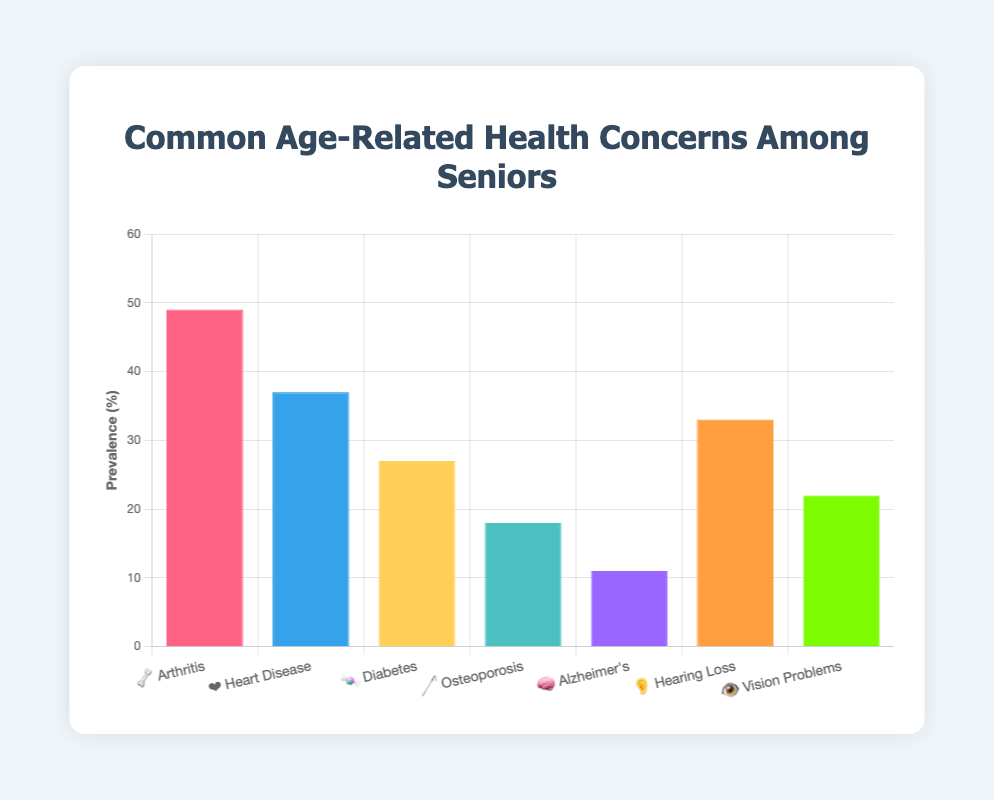Which health concern has the highest prevalence among seniors? Looking at the chart, identify the health concern with the tallest bar representing the highest prevalence percentage. "Arthritis" with an emoji 🦴 has the highest bar at 49%.
Answer: Arthritis 🦴 Which health concern has the lowest prevalence among seniors? Identify the health concern with the shortest bar representing the lowest prevalence percentage. "Alzheimer's" with an emoji 🧠 has the shortest bar at 11%.
Answer: Alzheimer's 🧠 What is the prevalence percentage of Hearing Loss? Observe the bar labeled with "👂 Hearing Loss" and identify the corresponding y-axis value. The percentage listed is 33%.
Answer: 33% How does the prevalence of Vision Problems compare to that of Diabetes? Compare the height of the bars for "👁️ Vision Problems" and "🍬 Diabetes". The bar for Diabetes is taller at 27% compared to Vision Problems at 22%.
Answer: Diabetes 🍬 is higher What is the total prevalence for Heart Disease and Osteoporosis combined? Add the prevalence percentages of "❤️ Heart Disease" (37%) and "🦯 Osteoporosis" (18%) together. 37 + 18 = 55.
Answer: 55% By how much does the prevalence of Arthritis exceed that of Heart Disease? Subtract the prevalence of "❤️ Heart Disease" (37%) from "🦴 Arthritis" (49%). 49 - 37 = 12.
Answer: 12% Which two health concerns have prevalence percentages within 10 units of each other? Identify bars with prevalence percentages within 10 units. "❤️ Heart Disease" (37%) and "👂 Hearing Loss" (33%) are 4 units apart, which is within 10.
Answer: Heart Disease ❤️ and Hearing Loss 👂 What is the average prevalence percentage of Diabetes and Vision Problems? Add the prevalence percentages of "🍬 Diabetes" (27%) and "👁️ Vision Problems" (22%) and divide by 2. (27 + 22) / 2 = 24.5.
Answer: 24.5% What percentage of seniors are dealing with Osteoporosis? Find the bar labeled "🦯 Osteoporosis" and note its height on the y-axis, which shows a prevalence of 18%.
Answer: 18% 